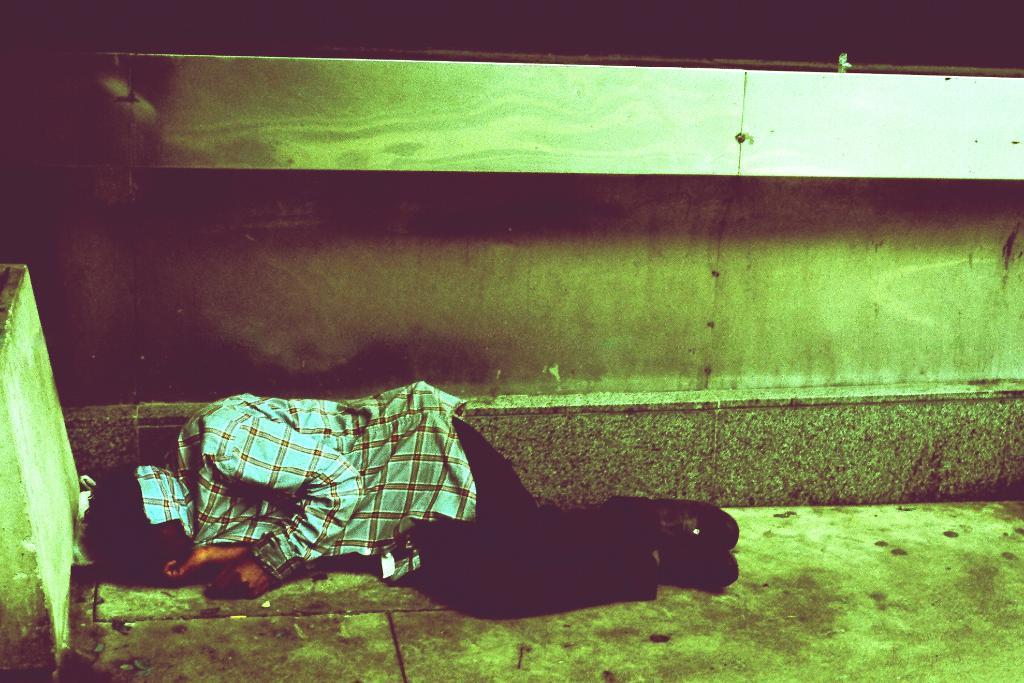What is the person in the image doing? The person is sleeping on the floor in the image. Where is the person located in the image? The person is at the bottom of the image. What can be seen in the background of the image? There is a wall in the background of the image. What is on the left side of the image? There is a pillar on the left side of the image. What type of development can be seen along the coast in the image? There is no coast or development present in the image; it features a person sleeping on the floor with a wall and pillar in the background. 